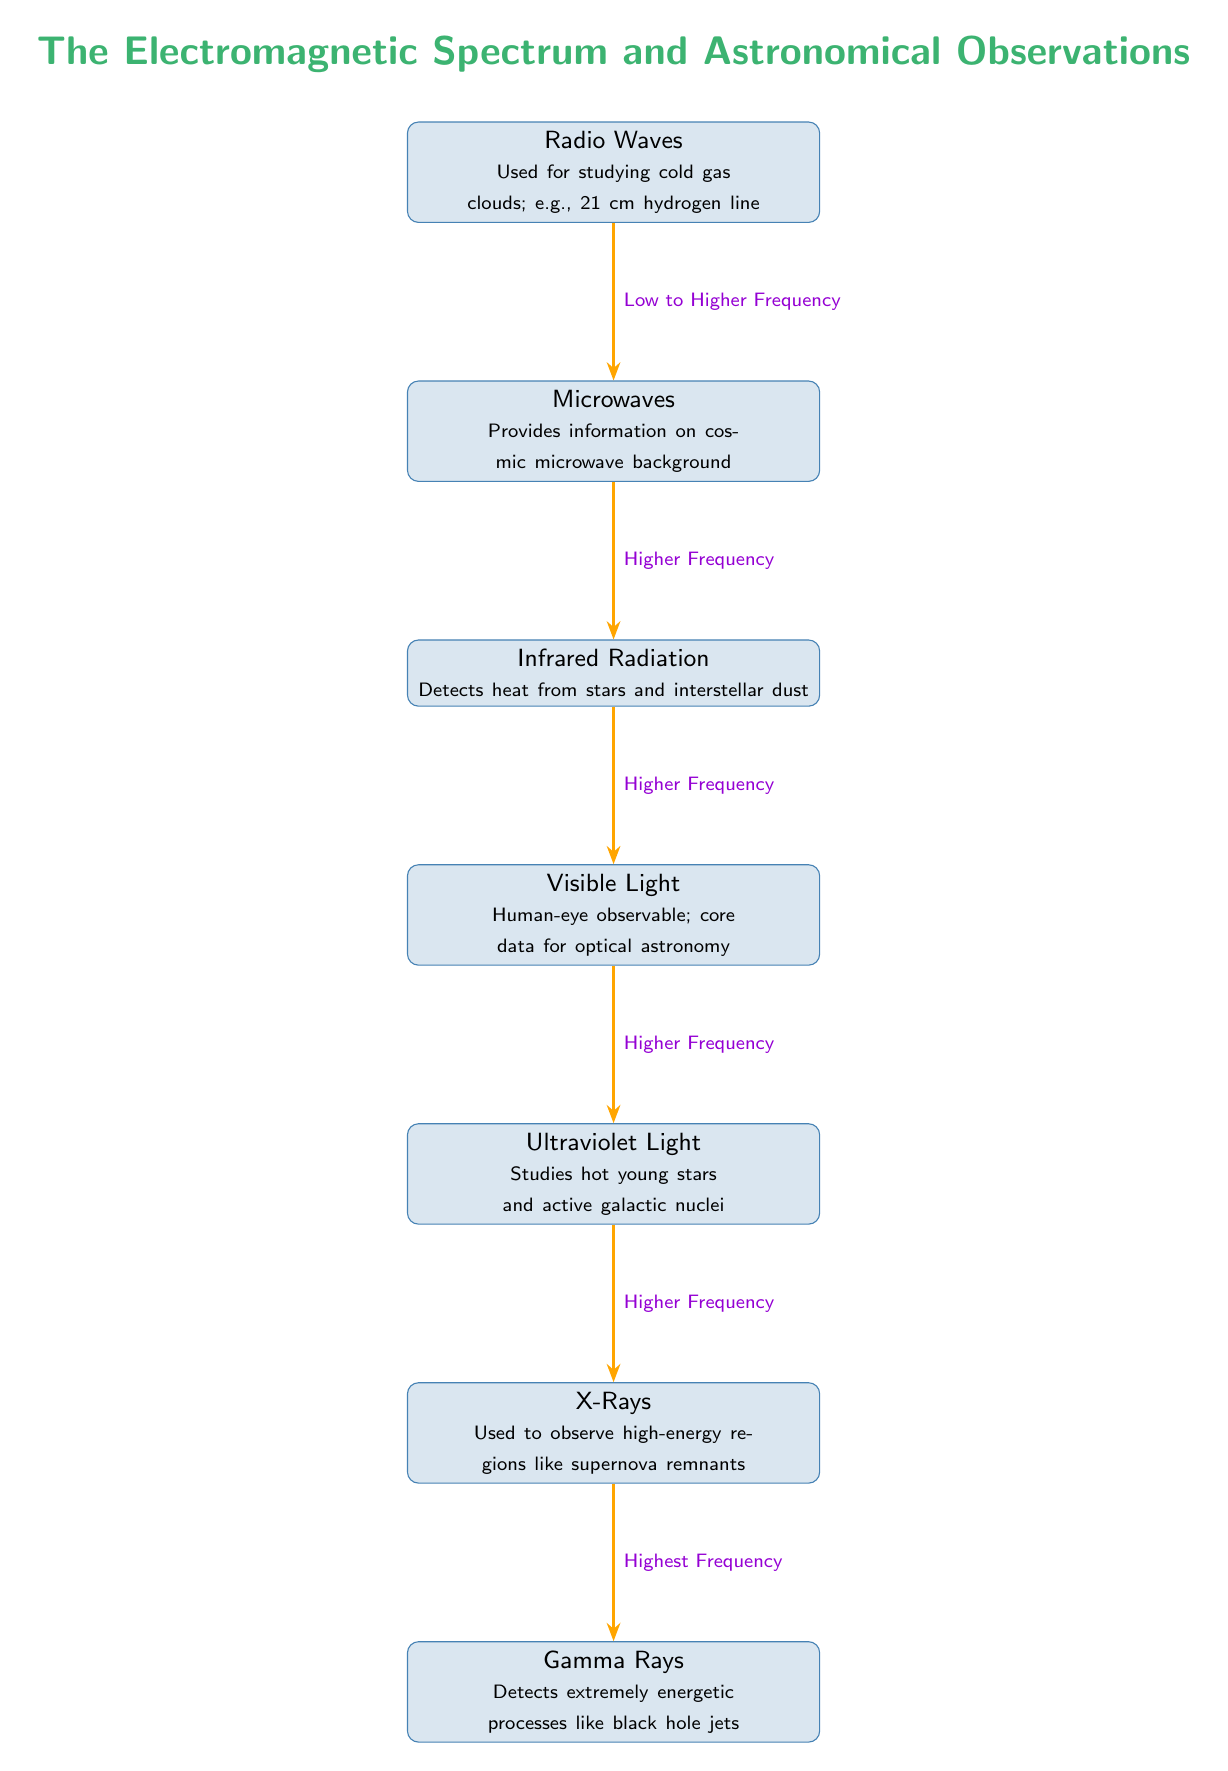What is the highest frequency in the electromagnetic spectrum shown? The diagram lists gamma rays at the bottom, indicating that it has the highest frequency among the shown types of electromagnetic radiation.
Answer: Gamma Rays What is used to study cold gas clouds according to the diagram? The diagram specifies that radio waves are used for studying cold gas clouds, as stated in the first node.
Answer: Radio Waves How many types of radiation are depicted in the diagram? There are seven nodes in the diagram representing different types of electromagnetic radiation, indicating that there are seven types displayed.
Answer: Seven Which type of radiation detects heat from stars? The infrared radiation node details the detection of heat from stars, making this the answer to the question.
Answer: Infrared Radiation What type of light is observable by the human eye? The visible light node clearly states that it is human-eye observable, thus answering the question regarding which type is visible.
Answer: Visible Light Which radiation type follows visible light in the spectrum sequence? The diagram shows that ultraviolet light comes directly after visible light in the arrangement, indicating it follows right after.
Answer: Ultraviolet Light What is the relationship between radio waves and microwaves in terms of frequency? The diagram indicates that the frequency increases from radio waves to microwaves, noting the progression of frequency in the electromagnetic spectrum.
Answer: Low to Higher Frequency What type of radiation is used to observe supernova remnants? According to the diagram, X-rays are utilized to observe high-energy regions like supernova remnants.
Answer: X-Rays Which type of electromagnetic radiation studies hot young stars? The ultraviolet light node specifies that it is concerned with studying hot young stars, corresponding directly with the inquiry.
Answer: Ultraviolet Light 